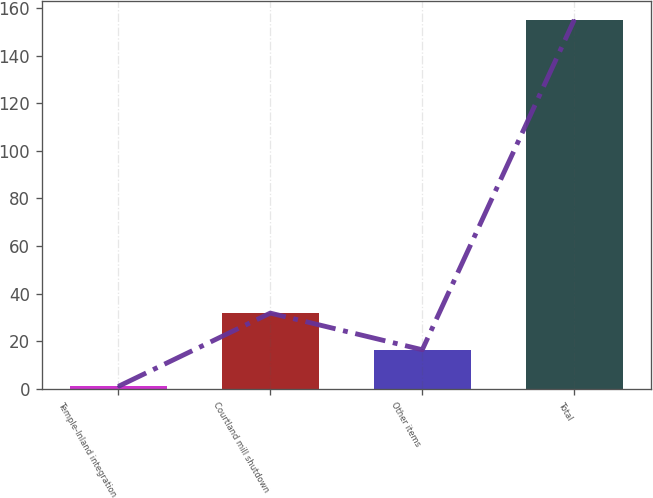Convert chart to OTSL. <chart><loc_0><loc_0><loc_500><loc_500><bar_chart><fcel>Temple-Inland integration<fcel>Courtland mill shutdown<fcel>Other items<fcel>Total<nl><fcel>1<fcel>31.8<fcel>16.4<fcel>155<nl></chart> 